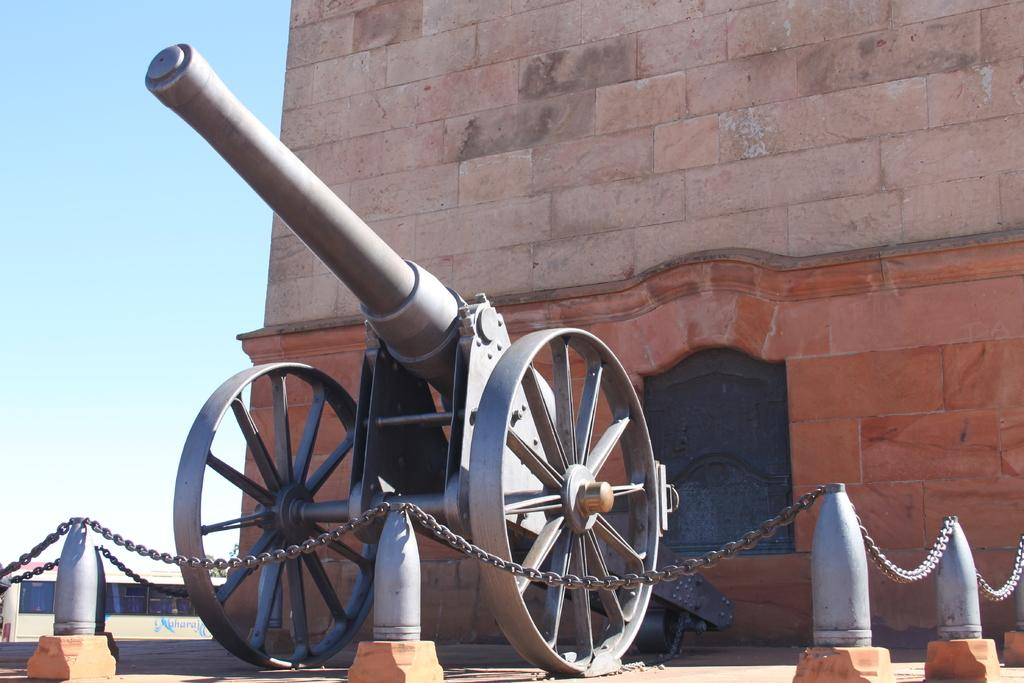What is the main object in the image? There is a cannon in the image. What can be seen in the background of the image? There is a building with brown and cream colors in the image. What is the color of the sky in the image? The sky is blue and white in the image. What other objects can be seen in the image? There is a chain visible in the image, as well as poles. What language is the cannon speaking in the image? Cannons do not speak, so there is no language present in the image. 